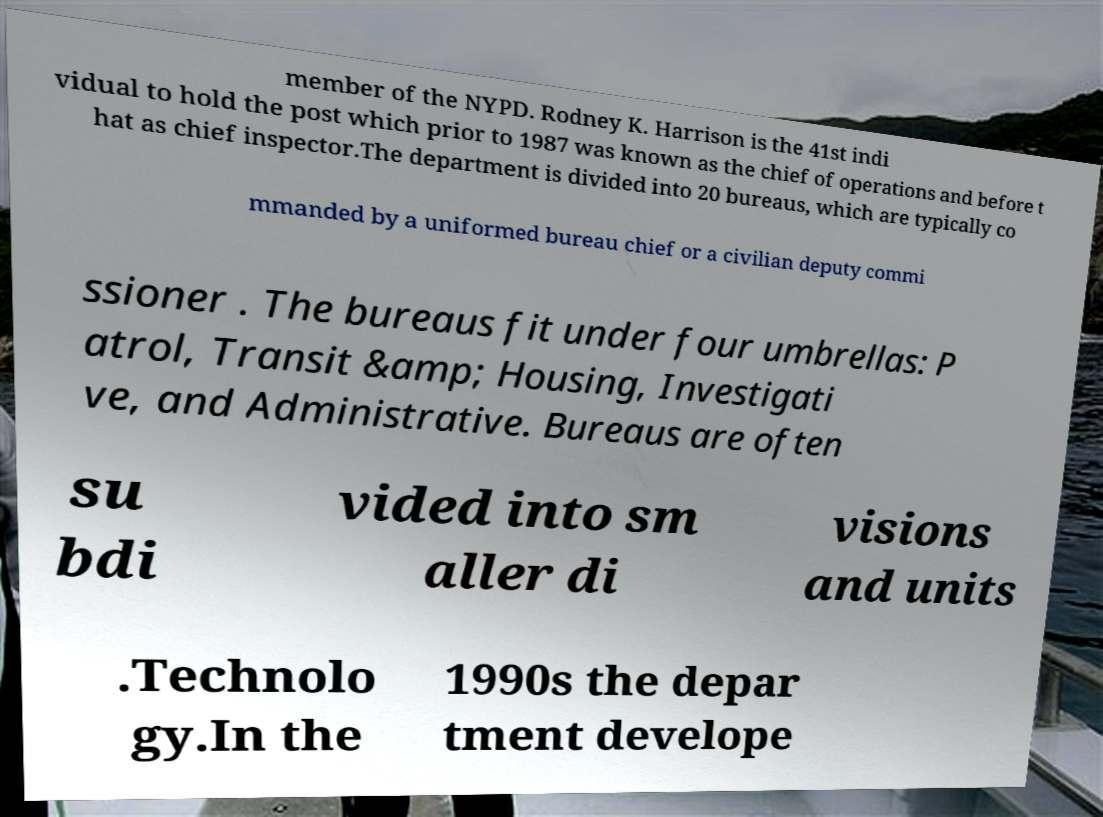Could you extract and type out the text from this image? member of the NYPD. Rodney K. Harrison is the 41st indi vidual to hold the post which prior to 1987 was known as the chief of operations and before t hat as chief inspector.The department is divided into 20 bureaus, which are typically co mmanded by a uniformed bureau chief or a civilian deputy commi ssioner . The bureaus fit under four umbrellas: P atrol, Transit &amp; Housing, Investigati ve, and Administrative. Bureaus are often su bdi vided into sm aller di visions and units .Technolo gy.In the 1990s the depar tment develope 